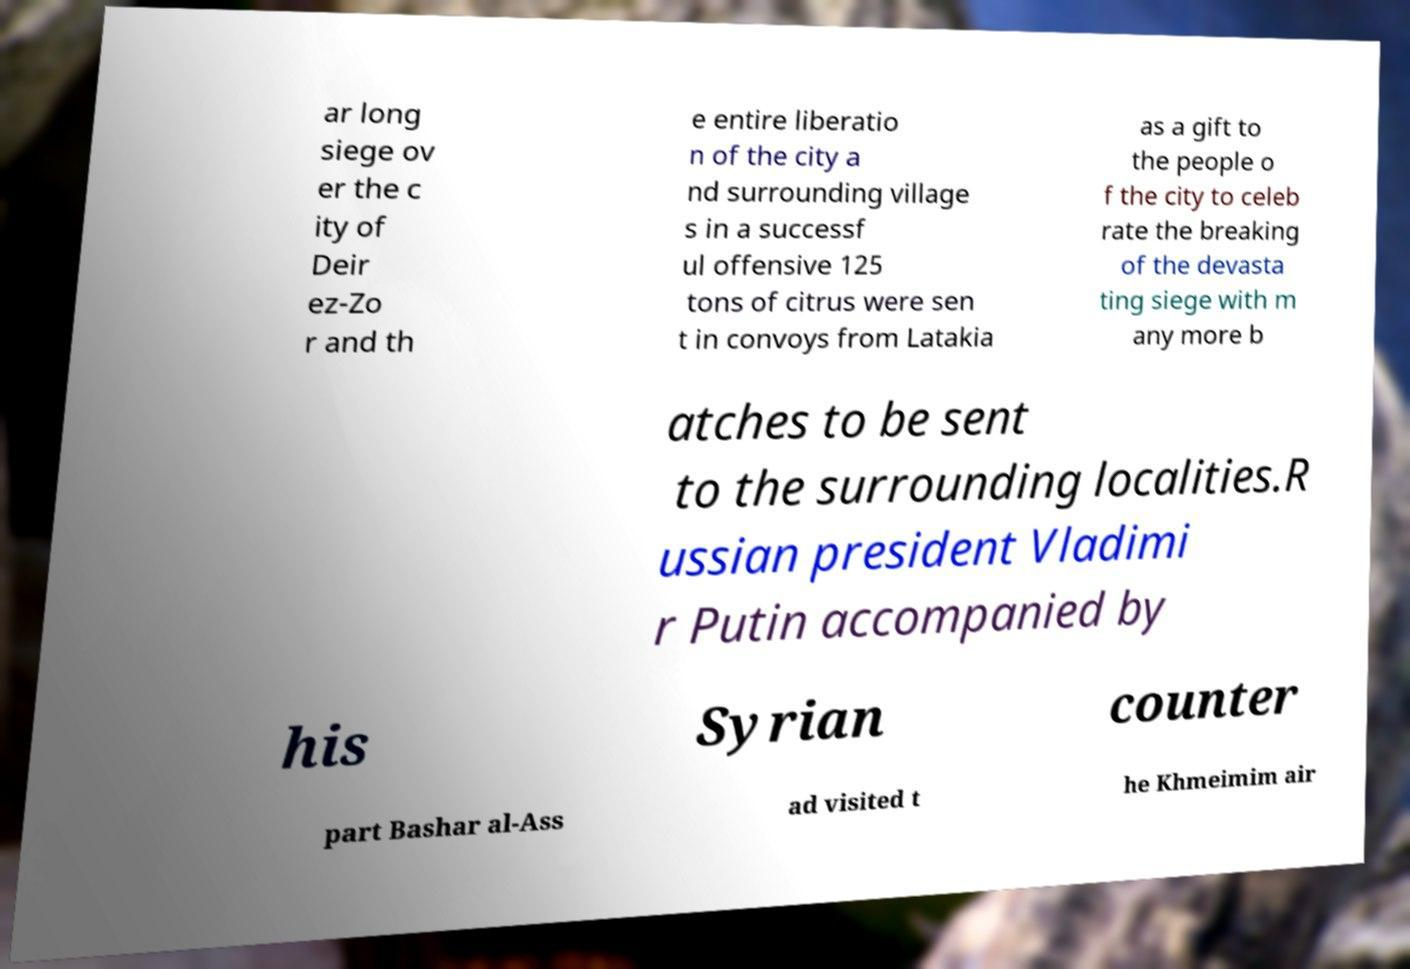Can you accurately transcribe the text from the provided image for me? ar long siege ov er the c ity of Deir ez-Zo r and th e entire liberatio n of the city a nd surrounding village s in a successf ul offensive 125 tons of citrus were sen t in convoys from Latakia as a gift to the people o f the city to celeb rate the breaking of the devasta ting siege with m any more b atches to be sent to the surrounding localities.R ussian president Vladimi r Putin accompanied by his Syrian counter part Bashar al-Ass ad visited t he Khmeimim air 